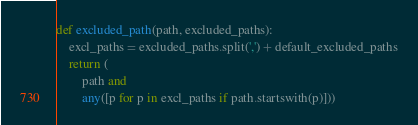Convert code to text. <code><loc_0><loc_0><loc_500><loc_500><_Python_>

def excluded_path(path, excluded_paths):
    excl_paths = excluded_paths.split(',') + default_excluded_paths
    return (
        path and
        any([p for p in excl_paths if path.startswith(p)]))
</code> 